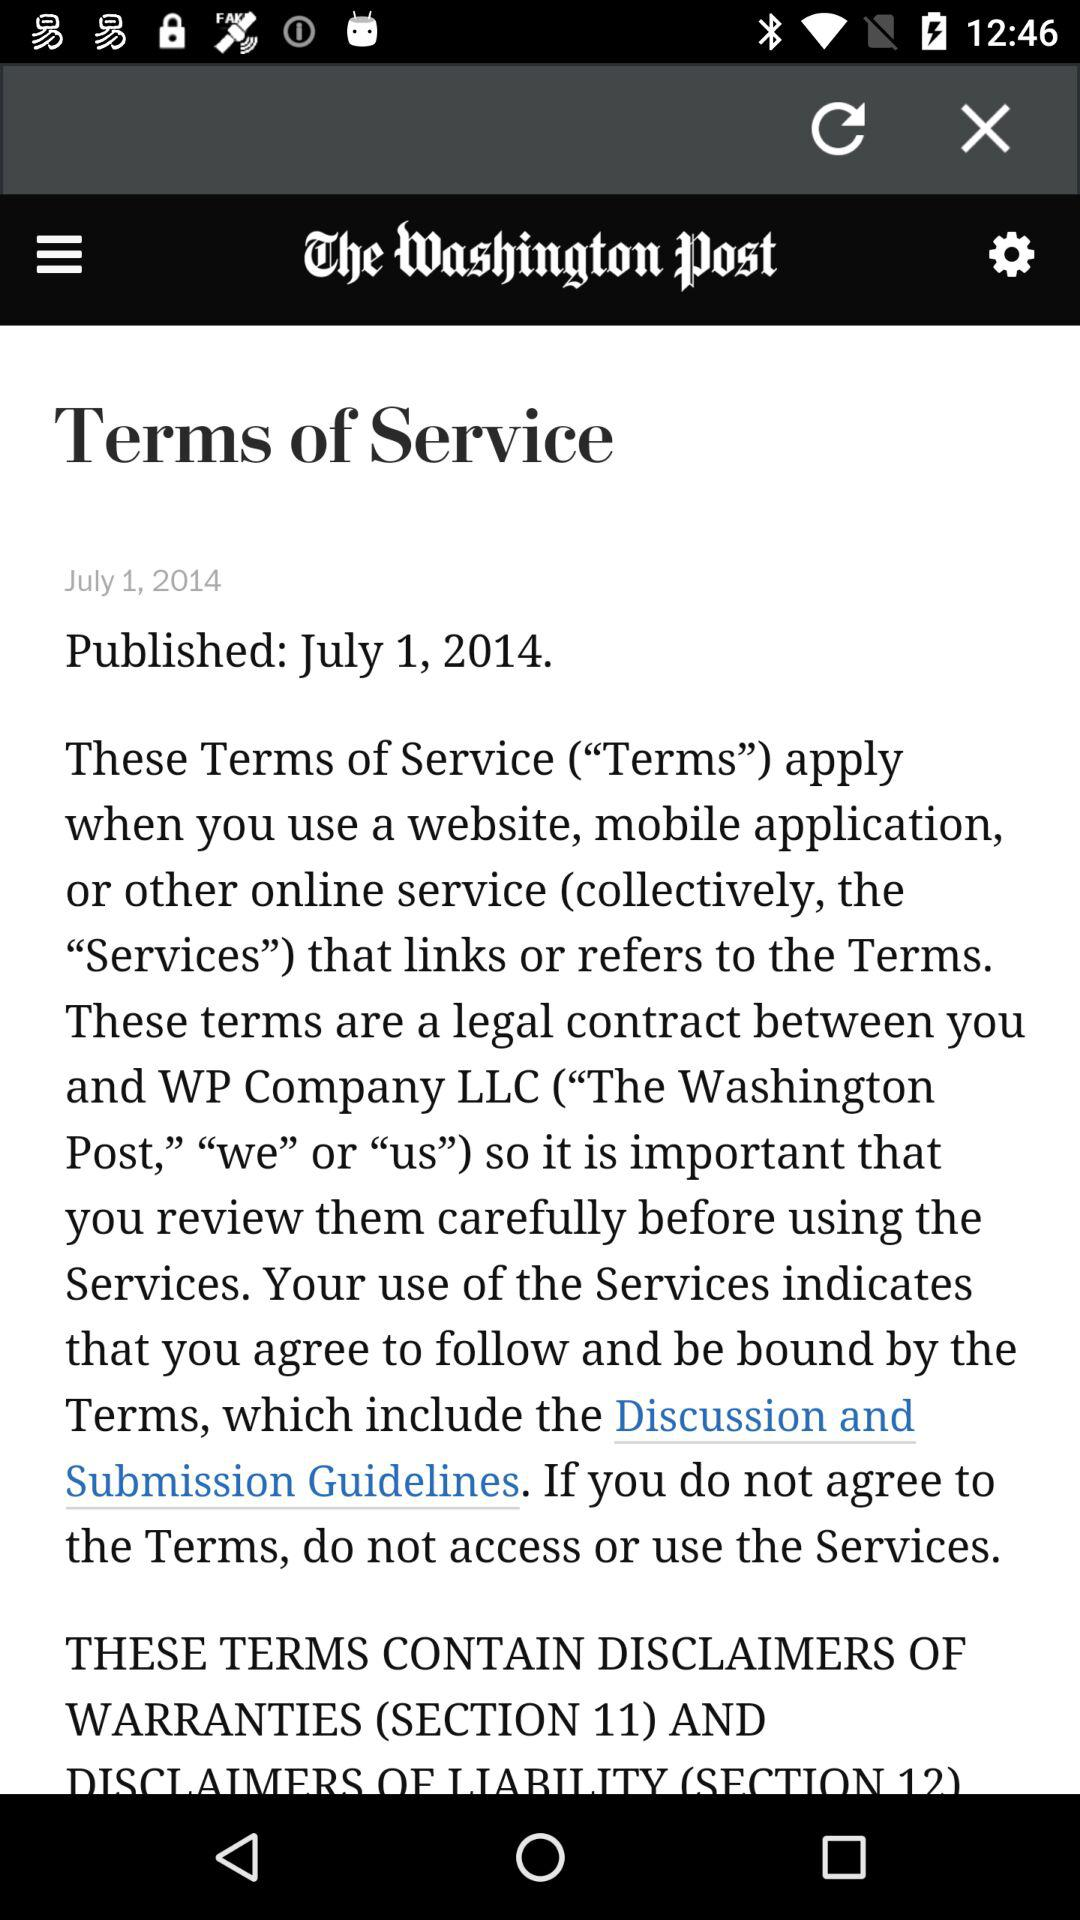When were "Terms of Service" published? "Terms of Service" were published on July 1, 2014. 